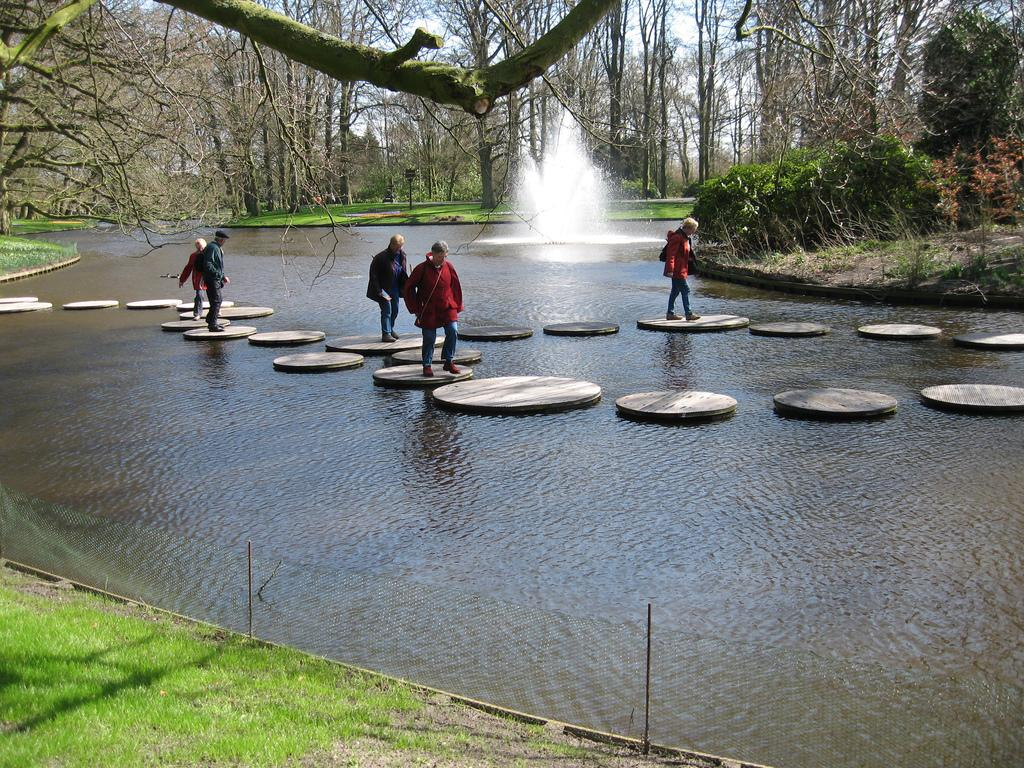What is located in the middle of the image? There are persons in the middle of the image. What can be seen in the background of the image? There is a fountain and trees in the background of the image. What is visible at the top of the image? The sky is visible at the top of the image. What type of sock is hanging from the fountain in the image? There is no sock present in the image, and therefore no such object can be observed hanging from the fountain. What flight number is associated with the persons in the image? There is no reference to a flight or flight number in the image, so it's not possible to determine any flight-related information. 